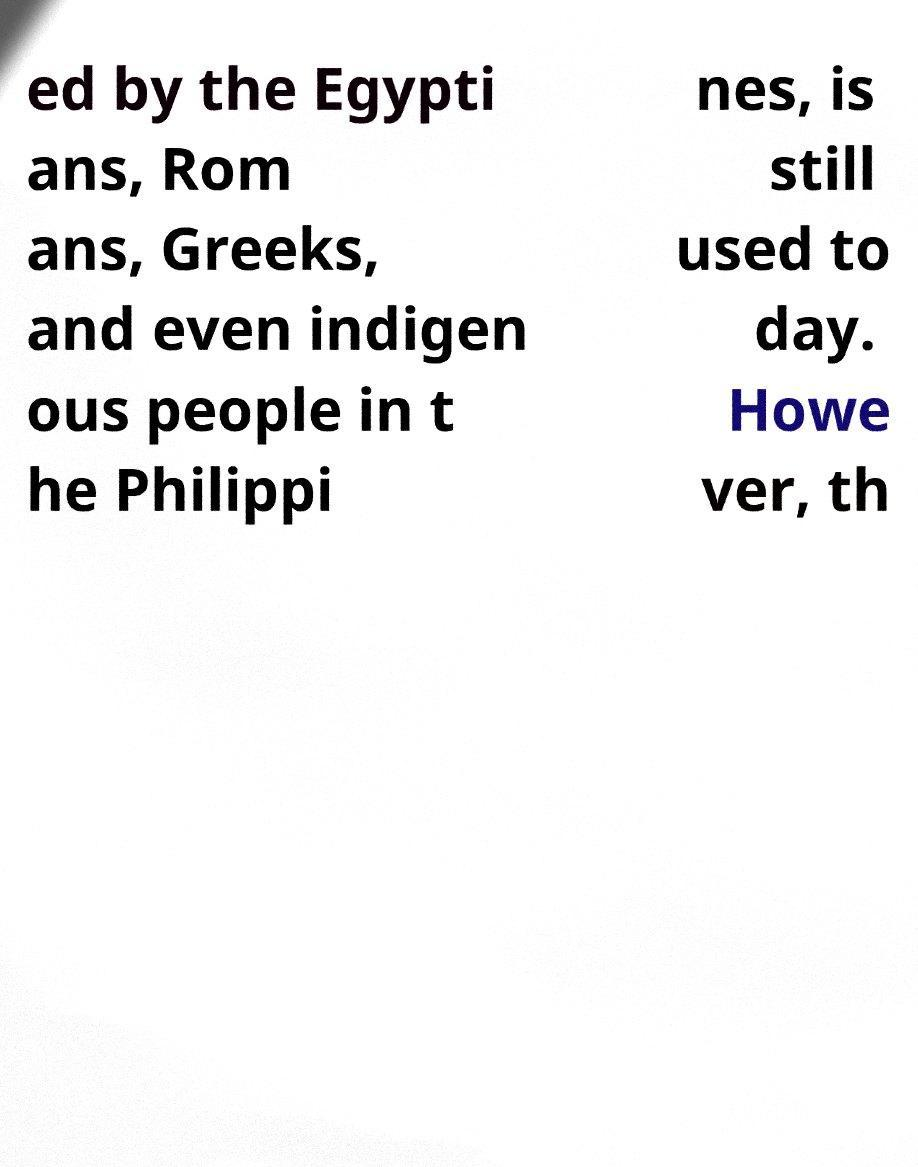For documentation purposes, I need the text within this image transcribed. Could you provide that? ed by the Egypti ans, Rom ans, Greeks, and even indigen ous people in t he Philippi nes, is still used to day. Howe ver, th 